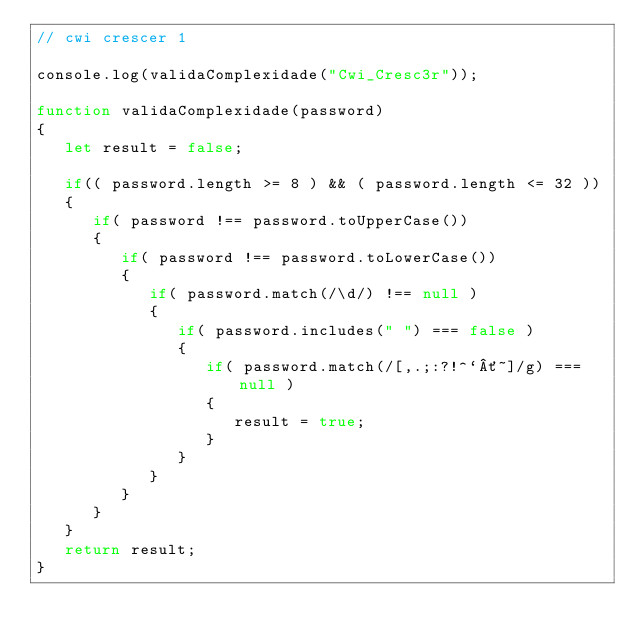<code> <loc_0><loc_0><loc_500><loc_500><_JavaScript_>// cwi crescer 1

console.log(validaComplexidade("Cwi_Cresc3r"));

function validaComplexidade(password)
{
   let result = false;

   if(( password.length >= 8 ) && ( password.length <= 32 ))
   {
      if( password !== password.toUpperCase())
      {
         if( password !== password.toLowerCase())
         {
            if( password.match(/\d/) !== null )
            {
               if( password.includes(" ") === false )
               {
                  if( password.match(/[,.;:?!^`´~]/g) === null )
                  {
                     result = true;
                  }
               }
            }
         }
      }
   }
   return result;
}</code> 